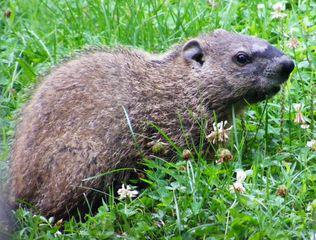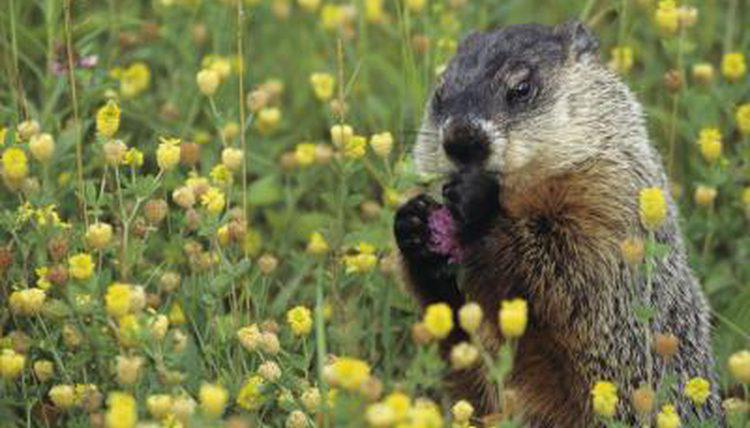The first image is the image on the left, the second image is the image on the right. Analyze the images presented: Is the assertion "the creature in the left image has its mouth wide open" valid? Answer yes or no. No. The first image is the image on the left, the second image is the image on the right. Considering the images on both sides, is "There are green fields in both of them." valid? Answer yes or no. Yes. 